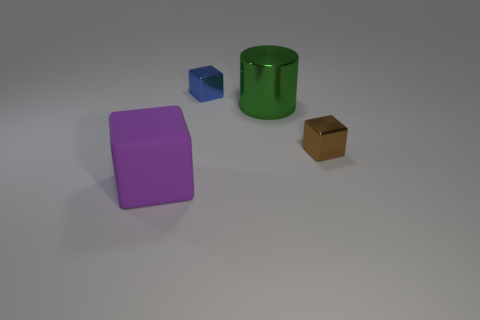Add 4 big blue cubes. How many objects exist? 8 Subtract all cylinders. How many objects are left? 3 Add 1 small brown metallic blocks. How many small brown metallic blocks are left? 2 Add 2 small gray rubber cubes. How many small gray rubber cubes exist? 2 Subtract 0 purple cylinders. How many objects are left? 4 Subtract all large shiny objects. Subtract all blue cubes. How many objects are left? 2 